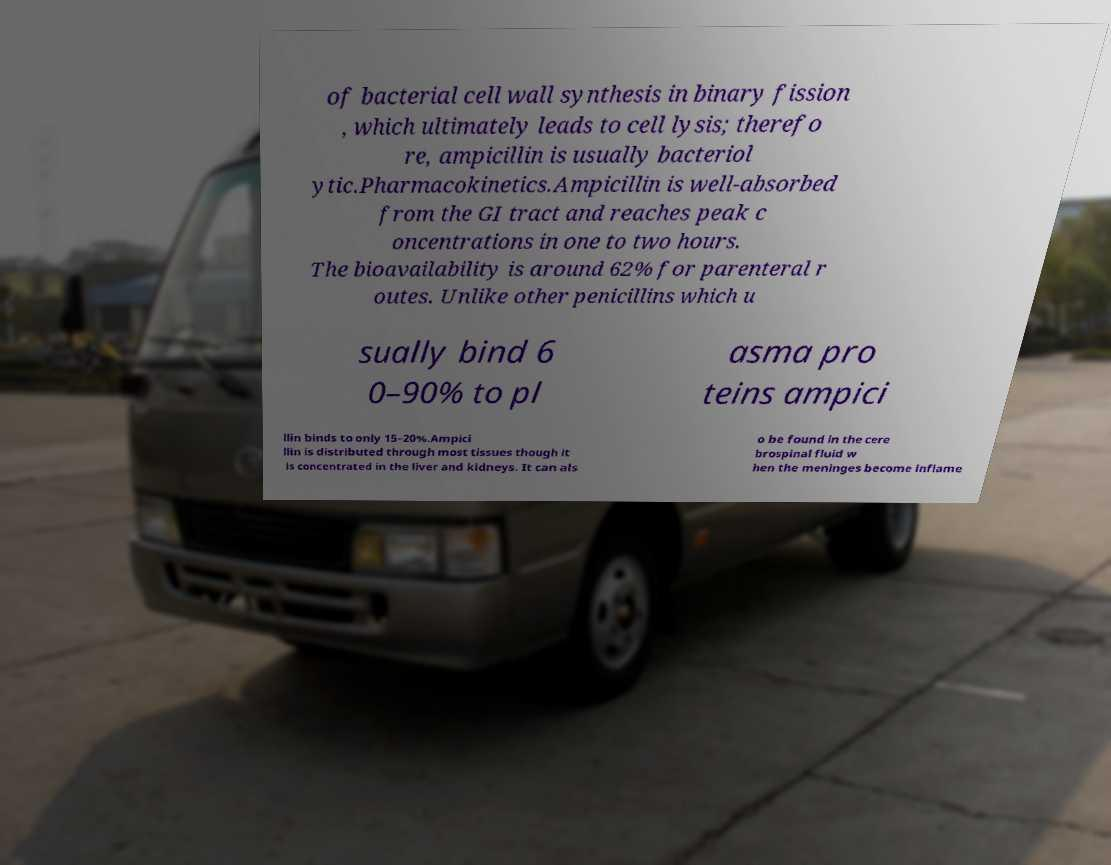Please read and relay the text visible in this image. What does it say? of bacterial cell wall synthesis in binary fission , which ultimately leads to cell lysis; therefo re, ampicillin is usually bacteriol ytic.Pharmacokinetics.Ampicillin is well-absorbed from the GI tract and reaches peak c oncentrations in one to two hours. The bioavailability is around 62% for parenteral r outes. Unlike other penicillins which u sually bind 6 0–90% to pl asma pro teins ampici llin binds to only 15–20%.Ampici llin is distributed through most tissues though it is concentrated in the liver and kidneys. It can als o be found in the cere brospinal fluid w hen the meninges become inflame 